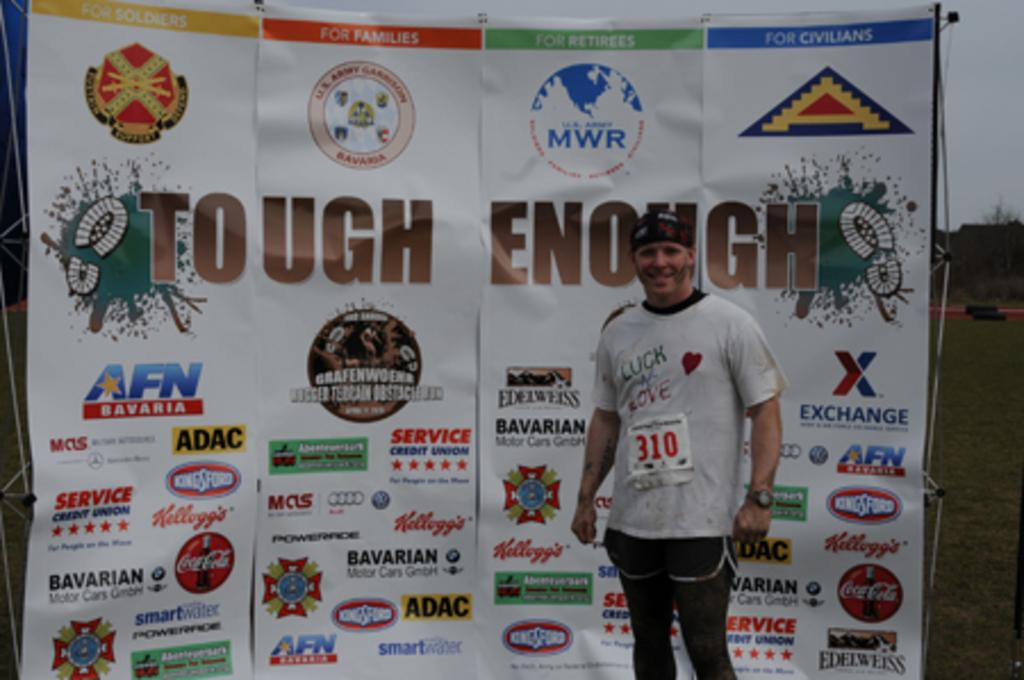<image>
Share a concise interpretation of the image provided. Man standing in front of a wall which says Tough Enough. 